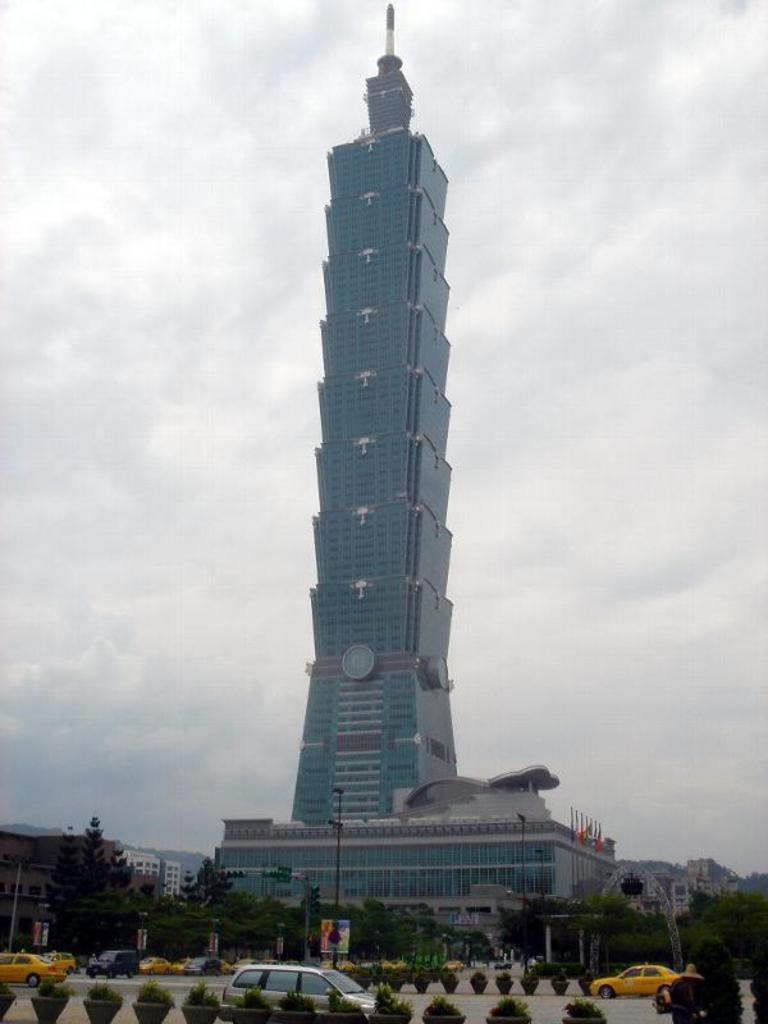What can be seen on the road in the image? There are vehicles on the road in the image. What type of objects are present near the vehicles? There are plant pots and poles in the image. What structures are visible in the image? There are buildings in the image. What type of vegetation is present in the image? There are trees in the image. What other objects can be seen on the ground in the image? There are other objects on the ground in the image. What can be seen on a building in the background of the image? There are clocks on a building in the background of the image. What is visible in the background of the image? The sky is visible in the background of the image. What type of grass is growing on the sofa in the image? There is no sofa or grass present in the image. How is the thread being used in the image? There is no thread present in the image. 